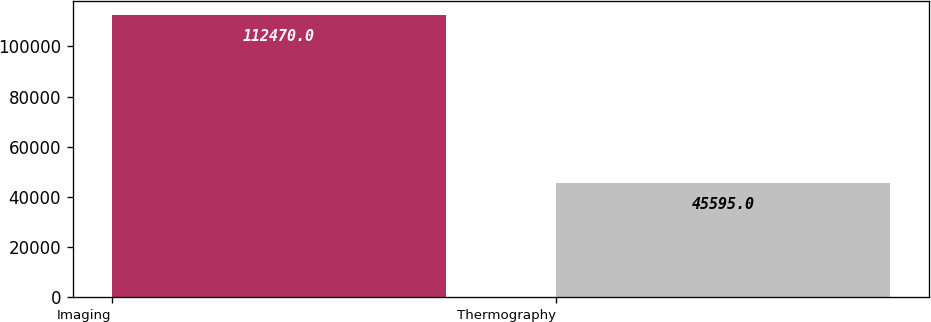Convert chart. <chart><loc_0><loc_0><loc_500><loc_500><bar_chart><fcel>Imaging<fcel>Thermography<nl><fcel>112470<fcel>45595<nl></chart> 